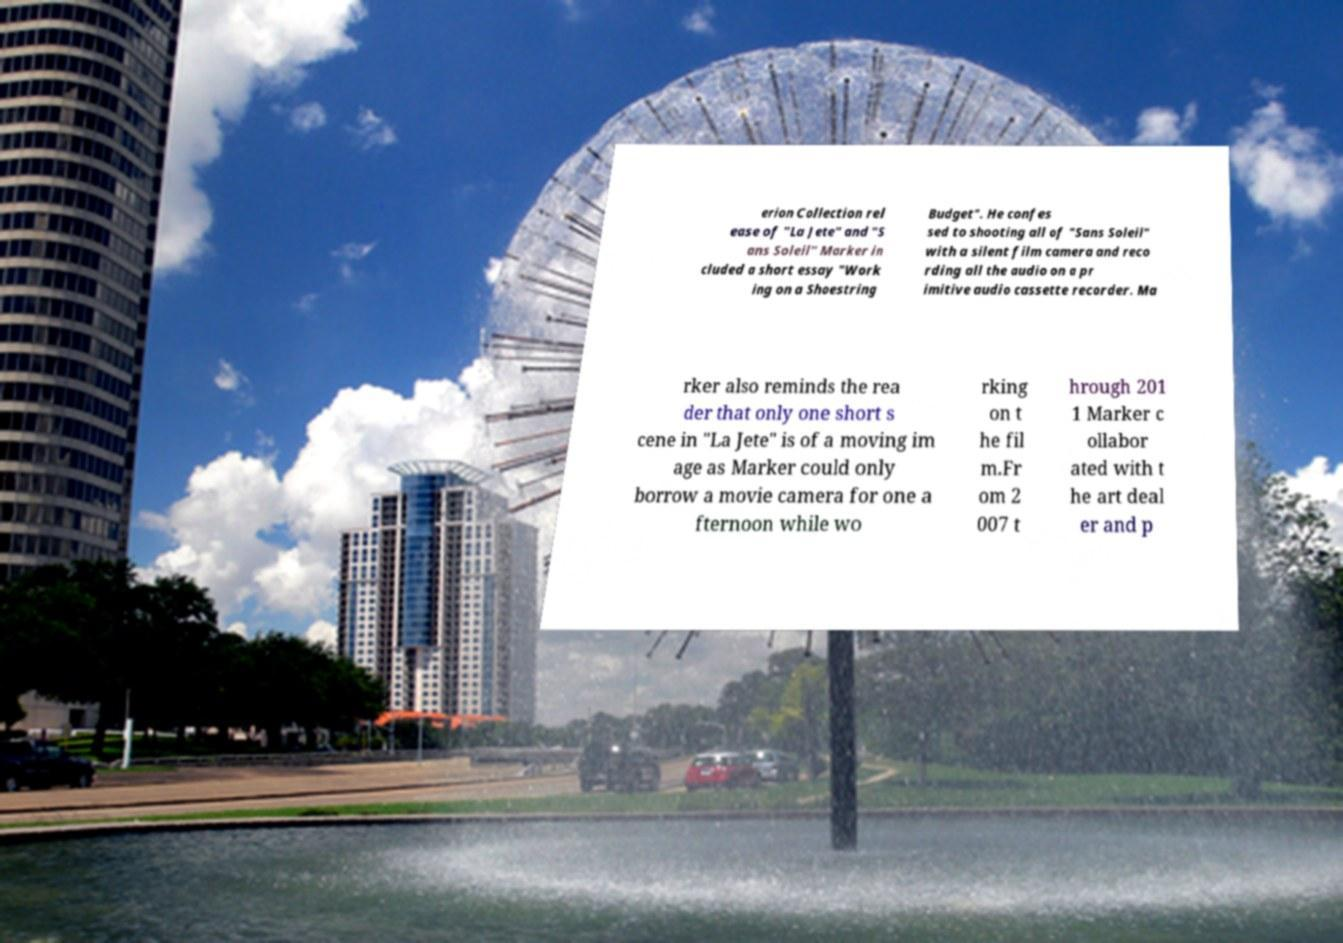Please identify and transcribe the text found in this image. erion Collection rel ease of "La Jete" and "S ans Soleil" Marker in cluded a short essay "Work ing on a Shoestring Budget". He confes sed to shooting all of "Sans Soleil" with a silent film camera and reco rding all the audio on a pr imitive audio cassette recorder. Ma rker also reminds the rea der that only one short s cene in "La Jete" is of a moving im age as Marker could only borrow a movie camera for one a fternoon while wo rking on t he fil m.Fr om 2 007 t hrough 201 1 Marker c ollabor ated with t he art deal er and p 